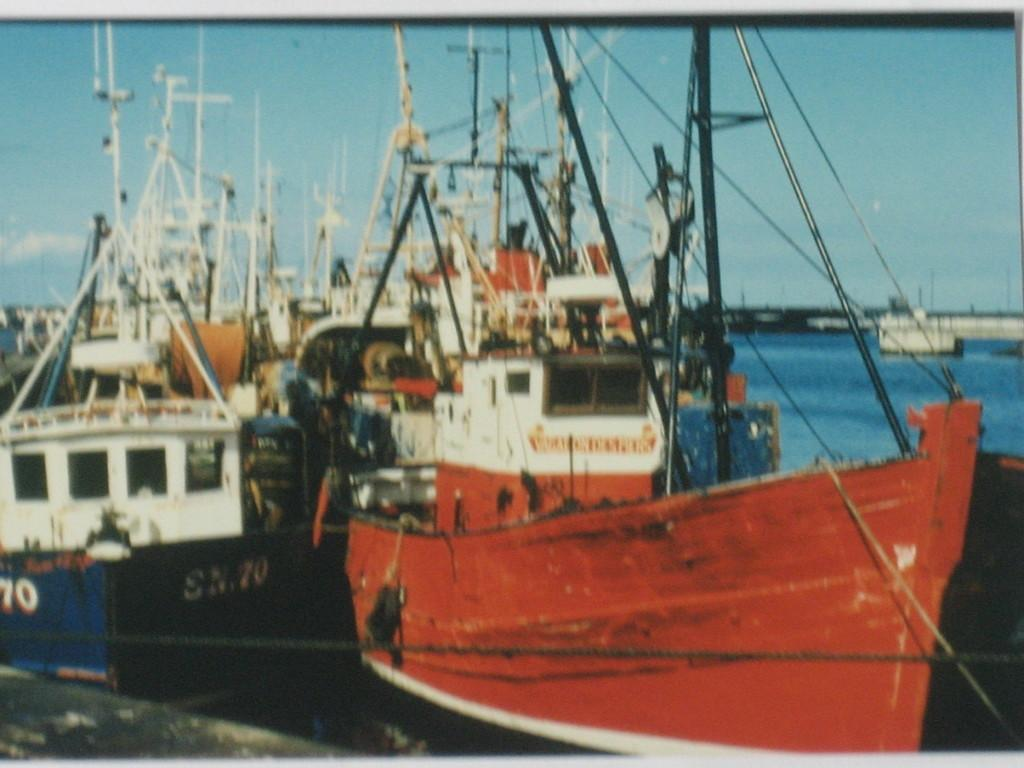Provide a one-sentence caption for the provided image. A ship labeled SN.70 sits next to another. 